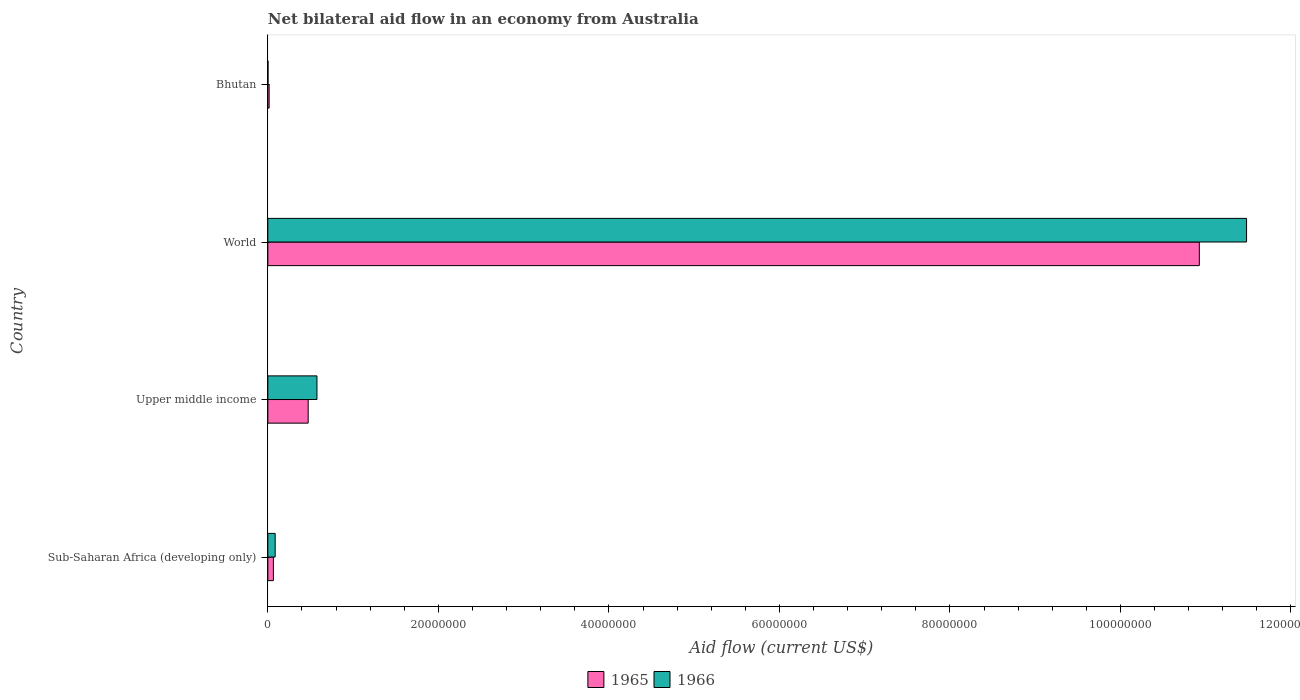Are the number of bars on each tick of the Y-axis equal?
Your answer should be compact. Yes. How many bars are there on the 1st tick from the top?
Provide a succinct answer. 2. How many bars are there on the 1st tick from the bottom?
Provide a succinct answer. 2. What is the label of the 4th group of bars from the top?
Keep it short and to the point. Sub-Saharan Africa (developing only). In how many cases, is the number of bars for a given country not equal to the number of legend labels?
Provide a succinct answer. 0. What is the net bilateral aid flow in 1966 in Upper middle income?
Offer a very short reply. 5.76e+06. Across all countries, what is the maximum net bilateral aid flow in 1966?
Make the answer very short. 1.15e+08. In which country was the net bilateral aid flow in 1966 minimum?
Offer a terse response. Bhutan. What is the total net bilateral aid flow in 1965 in the graph?
Your answer should be very brief. 1.15e+08. What is the difference between the net bilateral aid flow in 1966 in Bhutan and that in Upper middle income?
Provide a succinct answer. -5.74e+06. What is the difference between the net bilateral aid flow in 1965 in Bhutan and the net bilateral aid flow in 1966 in Sub-Saharan Africa (developing only)?
Your response must be concise. -7.10e+05. What is the average net bilateral aid flow in 1965 per country?
Offer a terse response. 2.87e+07. What is the difference between the net bilateral aid flow in 1965 and net bilateral aid flow in 1966 in Upper middle income?
Keep it short and to the point. -1.03e+06. What is the ratio of the net bilateral aid flow in 1966 in Upper middle income to that in World?
Ensure brevity in your answer.  0.05. What is the difference between the highest and the second highest net bilateral aid flow in 1965?
Offer a very short reply. 1.05e+08. What is the difference between the highest and the lowest net bilateral aid flow in 1966?
Provide a succinct answer. 1.15e+08. In how many countries, is the net bilateral aid flow in 1965 greater than the average net bilateral aid flow in 1965 taken over all countries?
Ensure brevity in your answer.  1. Is the sum of the net bilateral aid flow in 1965 in Sub-Saharan Africa (developing only) and World greater than the maximum net bilateral aid flow in 1966 across all countries?
Your response must be concise. No. What does the 1st bar from the top in Upper middle income represents?
Your response must be concise. 1966. What does the 1st bar from the bottom in Bhutan represents?
Your answer should be compact. 1965. How many bars are there?
Offer a terse response. 8. Are all the bars in the graph horizontal?
Ensure brevity in your answer.  Yes. What is the difference between two consecutive major ticks on the X-axis?
Keep it short and to the point. 2.00e+07. Where does the legend appear in the graph?
Offer a terse response. Bottom center. How many legend labels are there?
Keep it short and to the point. 2. What is the title of the graph?
Your response must be concise. Net bilateral aid flow in an economy from Australia. What is the label or title of the Y-axis?
Your answer should be very brief. Country. What is the Aid flow (current US$) in 1965 in Sub-Saharan Africa (developing only)?
Make the answer very short. 6.50e+05. What is the Aid flow (current US$) in 1966 in Sub-Saharan Africa (developing only)?
Offer a terse response. 8.60e+05. What is the Aid flow (current US$) of 1965 in Upper middle income?
Offer a terse response. 4.73e+06. What is the Aid flow (current US$) in 1966 in Upper middle income?
Your response must be concise. 5.76e+06. What is the Aid flow (current US$) of 1965 in World?
Give a very brief answer. 1.09e+08. What is the Aid flow (current US$) in 1966 in World?
Provide a short and direct response. 1.15e+08. What is the Aid flow (current US$) of 1965 in Bhutan?
Provide a short and direct response. 1.50e+05. Across all countries, what is the maximum Aid flow (current US$) in 1965?
Offer a very short reply. 1.09e+08. Across all countries, what is the maximum Aid flow (current US$) in 1966?
Your answer should be very brief. 1.15e+08. What is the total Aid flow (current US$) in 1965 in the graph?
Your answer should be compact. 1.15e+08. What is the total Aid flow (current US$) of 1966 in the graph?
Your answer should be compact. 1.21e+08. What is the difference between the Aid flow (current US$) in 1965 in Sub-Saharan Africa (developing only) and that in Upper middle income?
Your answer should be compact. -4.08e+06. What is the difference between the Aid flow (current US$) of 1966 in Sub-Saharan Africa (developing only) and that in Upper middle income?
Keep it short and to the point. -4.90e+06. What is the difference between the Aid flow (current US$) in 1965 in Sub-Saharan Africa (developing only) and that in World?
Your response must be concise. -1.09e+08. What is the difference between the Aid flow (current US$) of 1966 in Sub-Saharan Africa (developing only) and that in World?
Offer a terse response. -1.14e+08. What is the difference between the Aid flow (current US$) of 1966 in Sub-Saharan Africa (developing only) and that in Bhutan?
Your response must be concise. 8.40e+05. What is the difference between the Aid flow (current US$) of 1965 in Upper middle income and that in World?
Offer a very short reply. -1.05e+08. What is the difference between the Aid flow (current US$) in 1966 in Upper middle income and that in World?
Provide a short and direct response. -1.09e+08. What is the difference between the Aid flow (current US$) in 1965 in Upper middle income and that in Bhutan?
Keep it short and to the point. 4.58e+06. What is the difference between the Aid flow (current US$) in 1966 in Upper middle income and that in Bhutan?
Keep it short and to the point. 5.74e+06. What is the difference between the Aid flow (current US$) of 1965 in World and that in Bhutan?
Ensure brevity in your answer.  1.09e+08. What is the difference between the Aid flow (current US$) in 1966 in World and that in Bhutan?
Give a very brief answer. 1.15e+08. What is the difference between the Aid flow (current US$) in 1965 in Sub-Saharan Africa (developing only) and the Aid flow (current US$) in 1966 in Upper middle income?
Keep it short and to the point. -5.11e+06. What is the difference between the Aid flow (current US$) of 1965 in Sub-Saharan Africa (developing only) and the Aid flow (current US$) of 1966 in World?
Your response must be concise. -1.14e+08. What is the difference between the Aid flow (current US$) of 1965 in Sub-Saharan Africa (developing only) and the Aid flow (current US$) of 1966 in Bhutan?
Offer a very short reply. 6.30e+05. What is the difference between the Aid flow (current US$) of 1965 in Upper middle income and the Aid flow (current US$) of 1966 in World?
Keep it short and to the point. -1.10e+08. What is the difference between the Aid flow (current US$) of 1965 in Upper middle income and the Aid flow (current US$) of 1966 in Bhutan?
Your answer should be compact. 4.71e+06. What is the difference between the Aid flow (current US$) of 1965 in World and the Aid flow (current US$) of 1966 in Bhutan?
Provide a succinct answer. 1.09e+08. What is the average Aid flow (current US$) of 1965 per country?
Make the answer very short. 2.87e+07. What is the average Aid flow (current US$) of 1966 per country?
Offer a very short reply. 3.04e+07. What is the difference between the Aid flow (current US$) in 1965 and Aid flow (current US$) in 1966 in Upper middle income?
Offer a terse response. -1.03e+06. What is the difference between the Aid flow (current US$) in 1965 and Aid flow (current US$) in 1966 in World?
Provide a short and direct response. -5.54e+06. What is the ratio of the Aid flow (current US$) in 1965 in Sub-Saharan Africa (developing only) to that in Upper middle income?
Offer a terse response. 0.14. What is the ratio of the Aid flow (current US$) of 1966 in Sub-Saharan Africa (developing only) to that in Upper middle income?
Ensure brevity in your answer.  0.15. What is the ratio of the Aid flow (current US$) in 1965 in Sub-Saharan Africa (developing only) to that in World?
Ensure brevity in your answer.  0.01. What is the ratio of the Aid flow (current US$) in 1966 in Sub-Saharan Africa (developing only) to that in World?
Offer a terse response. 0.01. What is the ratio of the Aid flow (current US$) of 1965 in Sub-Saharan Africa (developing only) to that in Bhutan?
Provide a succinct answer. 4.33. What is the ratio of the Aid flow (current US$) in 1966 in Sub-Saharan Africa (developing only) to that in Bhutan?
Keep it short and to the point. 43. What is the ratio of the Aid flow (current US$) of 1965 in Upper middle income to that in World?
Your answer should be very brief. 0.04. What is the ratio of the Aid flow (current US$) in 1966 in Upper middle income to that in World?
Provide a succinct answer. 0.05. What is the ratio of the Aid flow (current US$) of 1965 in Upper middle income to that in Bhutan?
Offer a very short reply. 31.53. What is the ratio of the Aid flow (current US$) of 1966 in Upper middle income to that in Bhutan?
Your answer should be very brief. 288. What is the ratio of the Aid flow (current US$) in 1965 in World to that in Bhutan?
Your response must be concise. 728.33. What is the ratio of the Aid flow (current US$) in 1966 in World to that in Bhutan?
Provide a succinct answer. 5739.5. What is the difference between the highest and the second highest Aid flow (current US$) in 1965?
Your answer should be very brief. 1.05e+08. What is the difference between the highest and the second highest Aid flow (current US$) of 1966?
Ensure brevity in your answer.  1.09e+08. What is the difference between the highest and the lowest Aid flow (current US$) in 1965?
Ensure brevity in your answer.  1.09e+08. What is the difference between the highest and the lowest Aid flow (current US$) in 1966?
Give a very brief answer. 1.15e+08. 